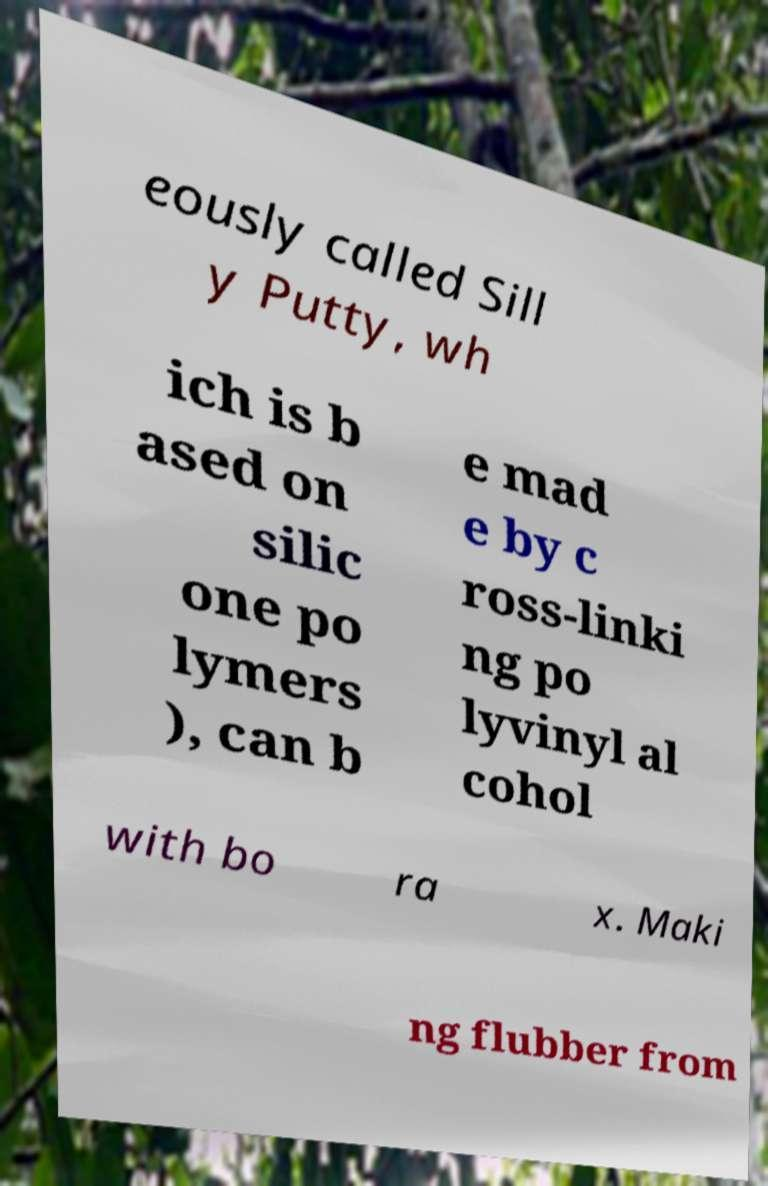Please identify and transcribe the text found in this image. eously called Sill y Putty, wh ich is b ased on silic one po lymers ), can b e mad e by c ross-linki ng po lyvinyl al cohol with bo ra x. Maki ng flubber from 